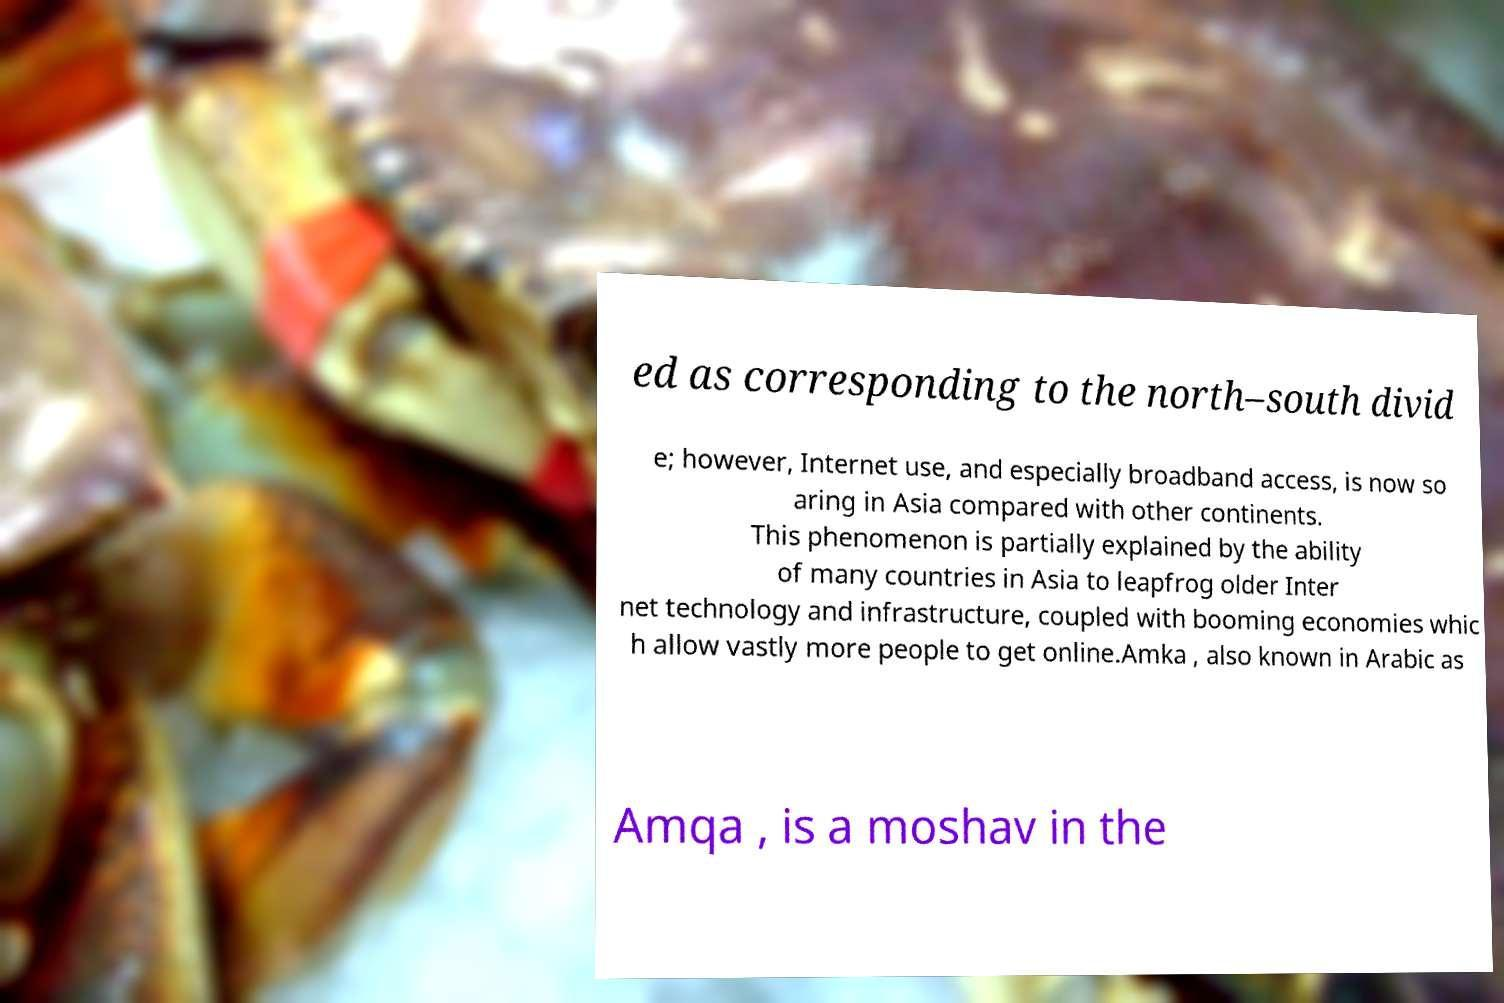For documentation purposes, I need the text within this image transcribed. Could you provide that? ed as corresponding to the north–south divid e; however, Internet use, and especially broadband access, is now so aring in Asia compared with other continents. This phenomenon is partially explained by the ability of many countries in Asia to leapfrog older Inter net technology and infrastructure, coupled with booming economies whic h allow vastly more people to get online.Amka , also known in Arabic as Amqa , is a moshav in the 